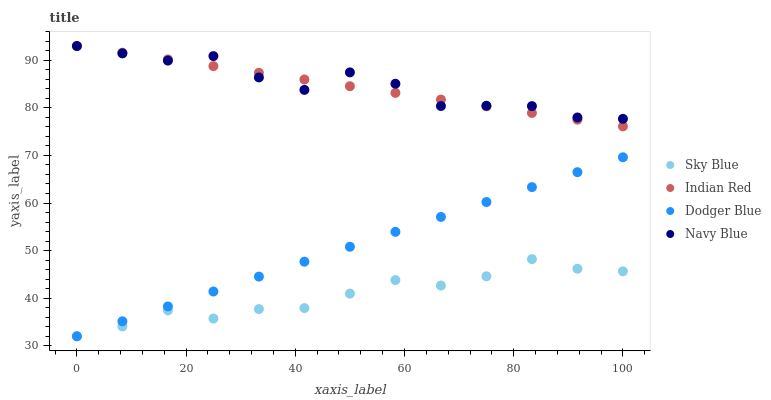Does Sky Blue have the minimum area under the curve?
Answer yes or no. Yes. Does Navy Blue have the maximum area under the curve?
Answer yes or no. Yes. Does Dodger Blue have the minimum area under the curve?
Answer yes or no. No. Does Dodger Blue have the maximum area under the curve?
Answer yes or no. No. Is Dodger Blue the smoothest?
Answer yes or no. Yes. Is Navy Blue the roughest?
Answer yes or no. Yes. Is Indian Red the smoothest?
Answer yes or no. No. Is Indian Red the roughest?
Answer yes or no. No. Does Sky Blue have the lowest value?
Answer yes or no. Yes. Does Indian Red have the lowest value?
Answer yes or no. No. Does Navy Blue have the highest value?
Answer yes or no. Yes. Does Dodger Blue have the highest value?
Answer yes or no. No. Is Sky Blue less than Indian Red?
Answer yes or no. Yes. Is Navy Blue greater than Sky Blue?
Answer yes or no. Yes. Does Navy Blue intersect Indian Red?
Answer yes or no. Yes. Is Navy Blue less than Indian Red?
Answer yes or no. No. Is Navy Blue greater than Indian Red?
Answer yes or no. No. Does Sky Blue intersect Indian Red?
Answer yes or no. No. 